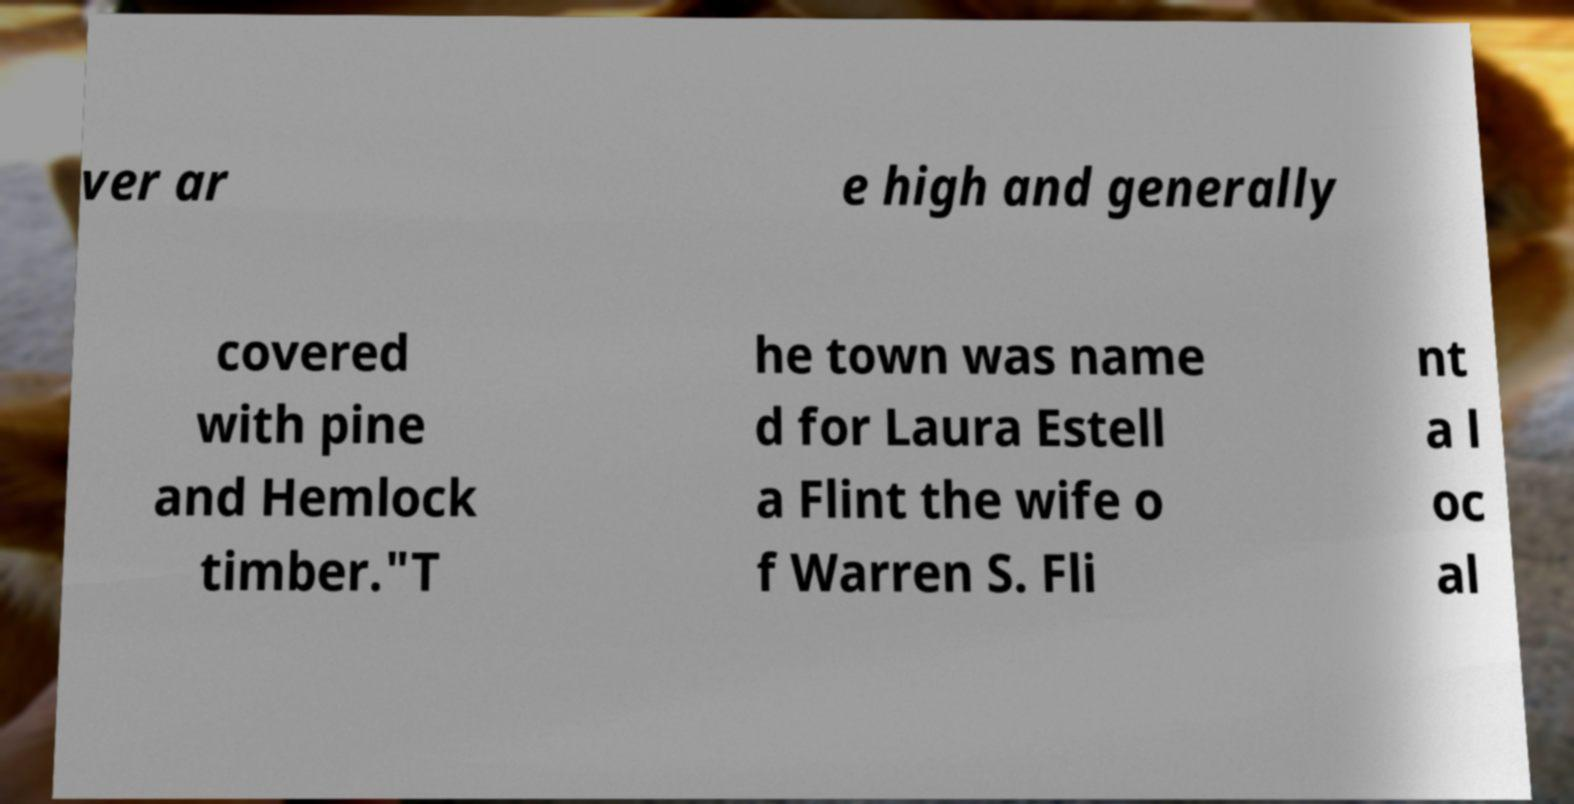Please identify and transcribe the text found in this image. ver ar e high and generally covered with pine and Hemlock timber."T he town was name d for Laura Estell a Flint the wife o f Warren S. Fli nt a l oc al 